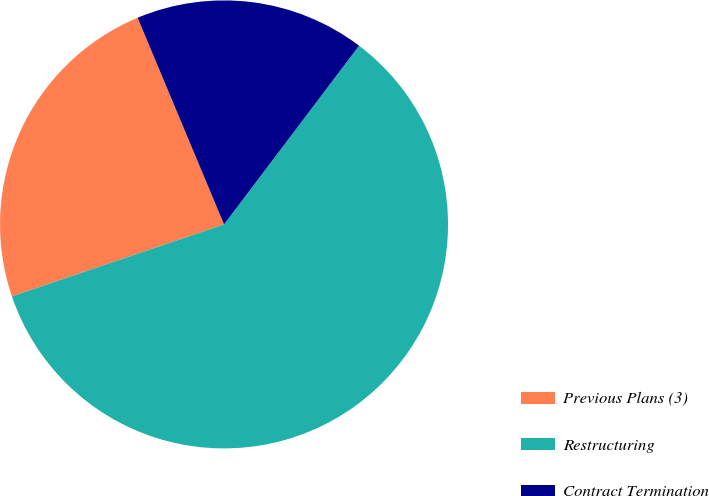Convert chart. <chart><loc_0><loc_0><loc_500><loc_500><pie_chart><fcel>Previous Plans (3)<fcel>Restructuring<fcel>Contract Termination<nl><fcel>23.9%<fcel>59.49%<fcel>16.6%<nl></chart> 